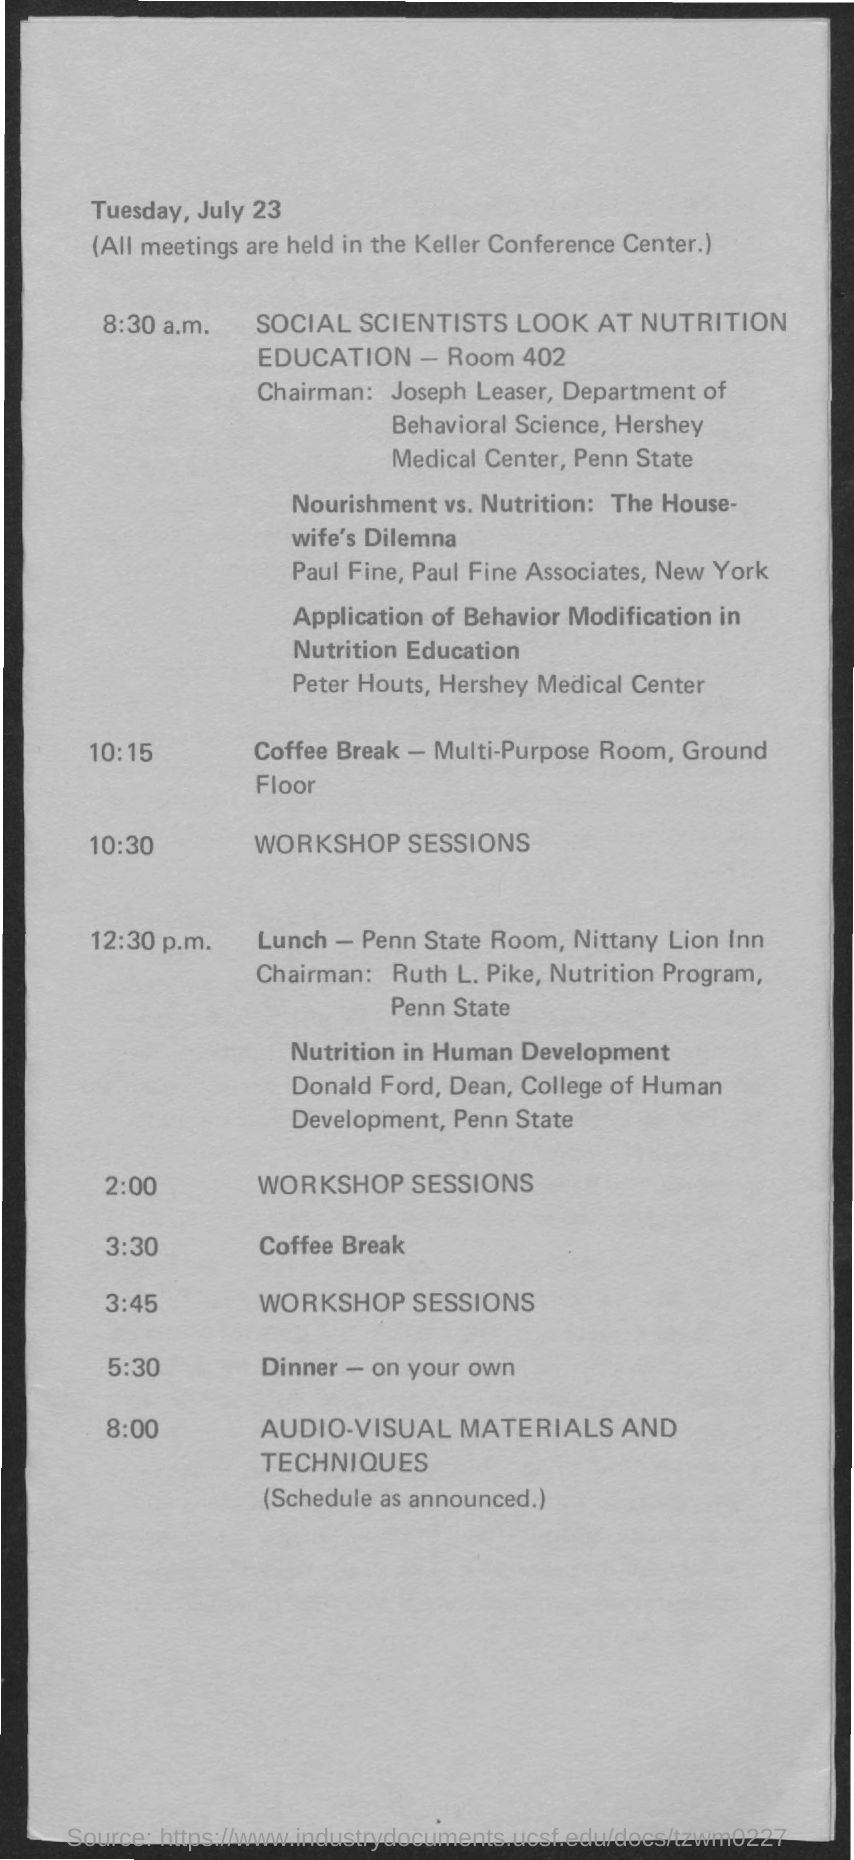Highlight a few significant elements in this photo. As per the given schedule, the time for lunch is 12:30 p.m. At 10:30, the schedule includes workshop sessions. At 8:30 a.m., social scientists focus on studying nutrition education. The dinner time according to the given schedule is 5:30. The person named Joseph Leaser belongs to the department of behavioral science. 